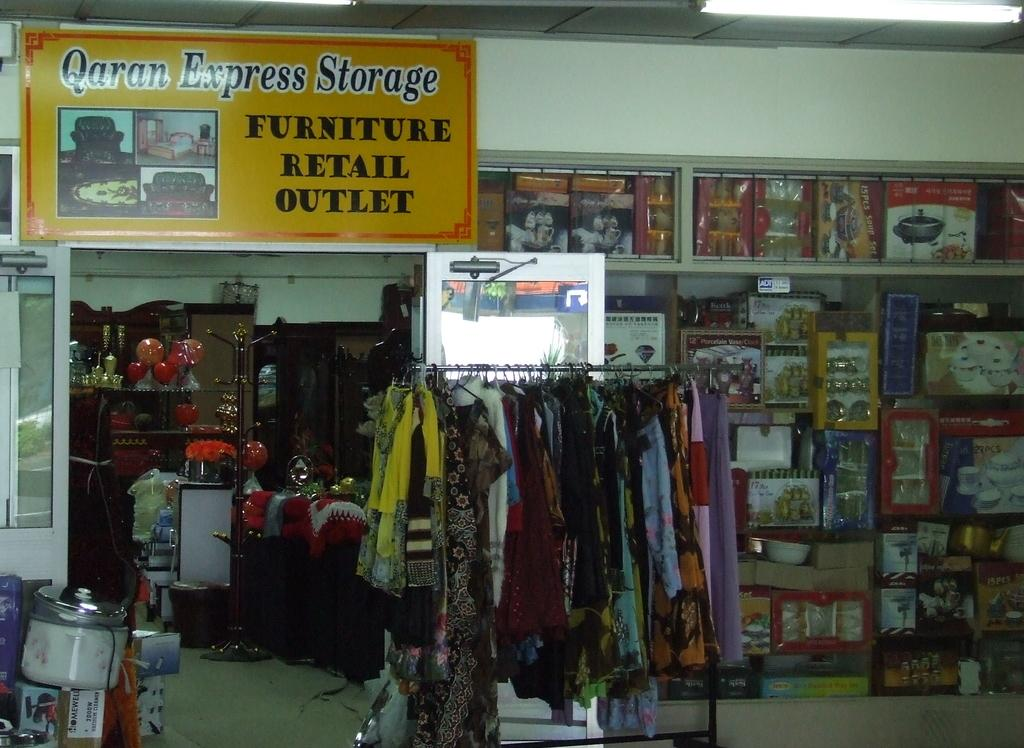<image>
Give a short and clear explanation of the subsequent image. The Qaran Express storage store has multiple different items on display. 